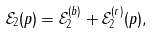Convert formula to latex. <formula><loc_0><loc_0><loc_500><loc_500>\mathcal { E } _ { 2 } ( p ) = \mathcal { E } _ { 2 } ^ { ( b ) } + \mathcal { E } _ { 2 } ^ { ( r ) } ( p ) ,</formula> 